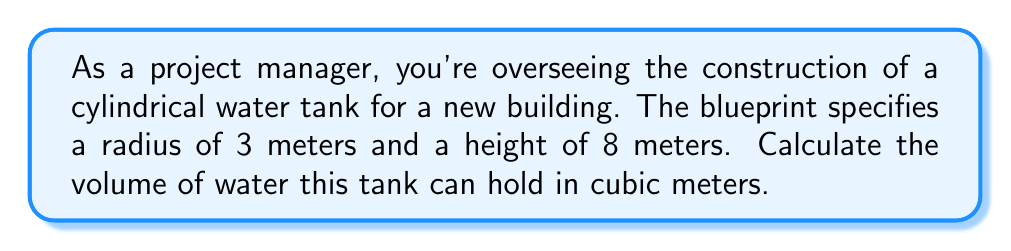Teach me how to tackle this problem. Let's approach this step-by-step:

1) The formula for the volume of a cylinder is:
   $$V = \pi r^2 h$$
   where $V$ is volume, $r$ is radius, and $h$ is height.

2) We're given:
   $r = 3$ meters
   $h = 8$ meters

3) Let's substitute these values into our formula:
   $$V = \pi (3\text{ m})^2 (8\text{ m})$$

4) Simplify the squared term:
   $$V = \pi (9\text{ m}^2) (8\text{ m})$$

5) Multiply the numbers:
   $$V = 72\pi\text{ m}^3$$

6) Calculate the final result (rounded to two decimal places):
   $$V \approx 226.19\text{ m}^3$$

Just as a blueprint provides precise measurements for construction, this calculation gives us the exact volume of the water tank, essential for proper planning and implementation.
Answer: $226.19\text{ m}^3$ 